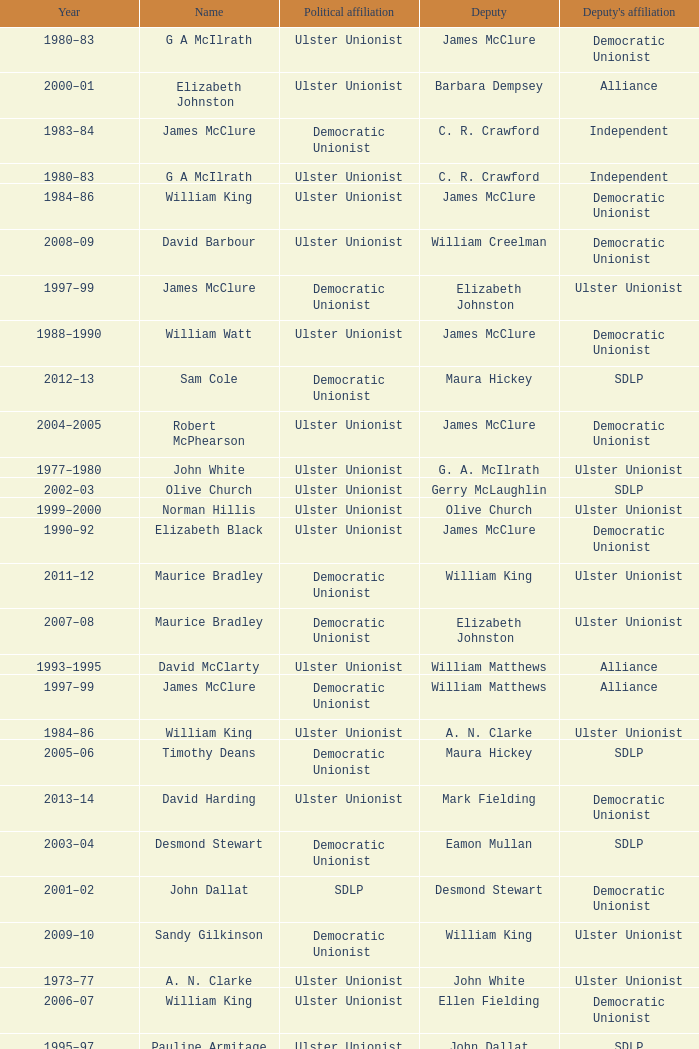What is the Deputy's affiliation in 1992–93? Democratic Unionist. 